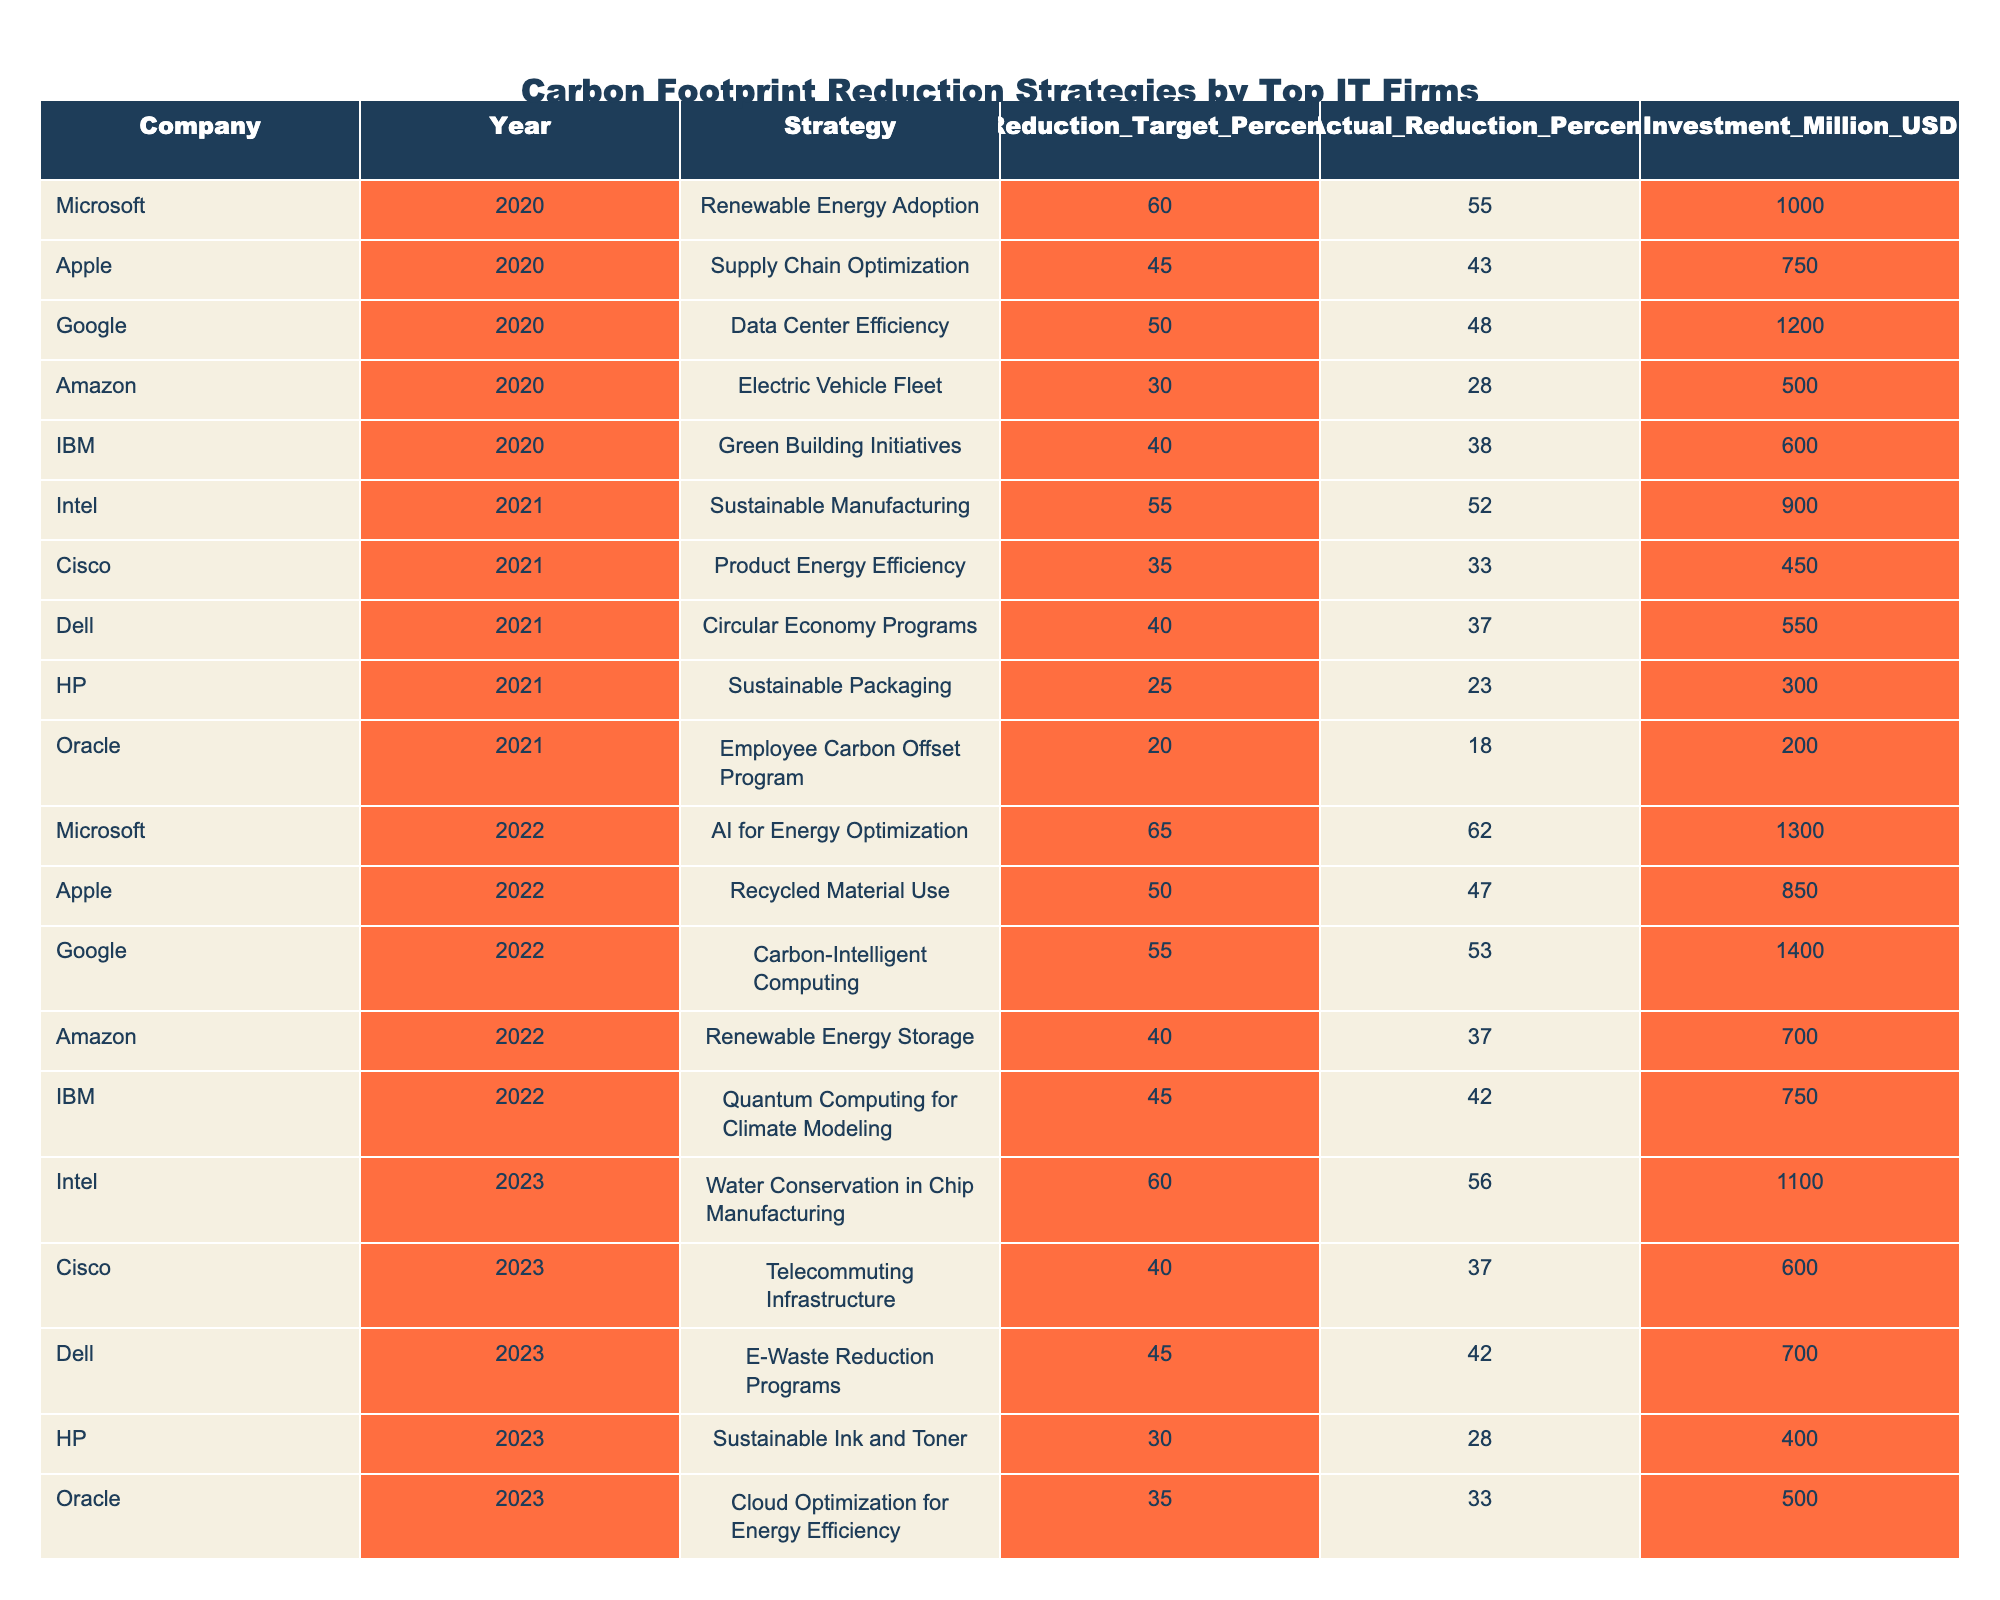What was the total investment made by Microsoft for carbon footprint reduction strategies in 2020, 2022, and 2023? Microsoft invested $1000 million in 2020, $1300 million in 2022, and there are no investments listed for 2023. Therefore, the total investment is $1000 + $1300 = $2300 million.
Answer: 2300 million USD Which company implemented the highest reduction target in 2021? In 2021, Intel had the highest reduction target of 55%. The other companies had lower targets: Cisco at 35%, Dell at 40%, HP at 25%, and Oracle at 20%. Therefore, Intel leads in 2021.
Answer: Intel Did any company achieve an actual reduction percentage that was higher than their reduction target percentage in any year? No, all companies reported actual reductions that were lower than their targets for each respective year in the data provided.
Answer: No What is the average actual reduction percentage achieved by Google over the years listed? Google achieved actual reductions of 48% in 2020 and 53% in 2022. To calculate the average, we sum these two percentages (48 + 53 = 101) and divide by the number of years (2), resulting in an average of 50.5%.
Answer: 50.5% Which company allocated the least investment in 2023 and what was the amount? HP allocated the least investment in 2023 with an amount of $400 million. Other companies had higher investments: Cisco at $600 million, Dell at $700 million, and Oracle at $500 million.
Answer: 400 million USD What was the difference in the actual reduction percentages achieved by Dell from 2021 to 2023? Dell achieved 37% actual reduction in 2021 and 42% in 2023. The difference is 42 - 37 = 5%.
Answer: 5% How many companies had a carbon footprint reduction strategy that targeted renewable energy between 2020 and 2022? Microsoft in 2020 achieved renewable energy adoption. In 2022, Amazon targeted renewable energy storage. Thus, there are two companies that had renewable energy strategies in this period.
Answer: 2 companies Which strategy had the lowest actual reduction percentage across all years? HP's Sustainable Packaging strategy had the lowest actual reduction at 23% in 2021 and 28% in 2023. This is less than any other values across all years for the listed companies.
Answer: 23% 